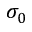<formula> <loc_0><loc_0><loc_500><loc_500>\sigma _ { 0 }</formula> 